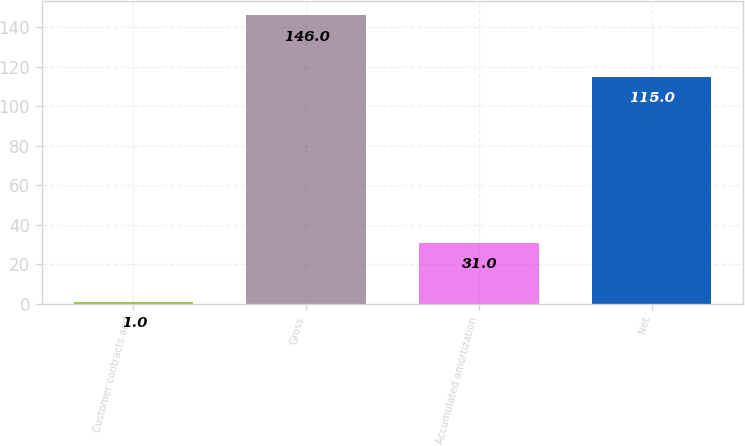Convert chart to OTSL. <chart><loc_0><loc_0><loc_500><loc_500><bar_chart><fcel>Customer contracts and<fcel>Gross<fcel>Accumulated amortization<fcel>Net<nl><fcel>1<fcel>146<fcel>31<fcel>115<nl></chart> 